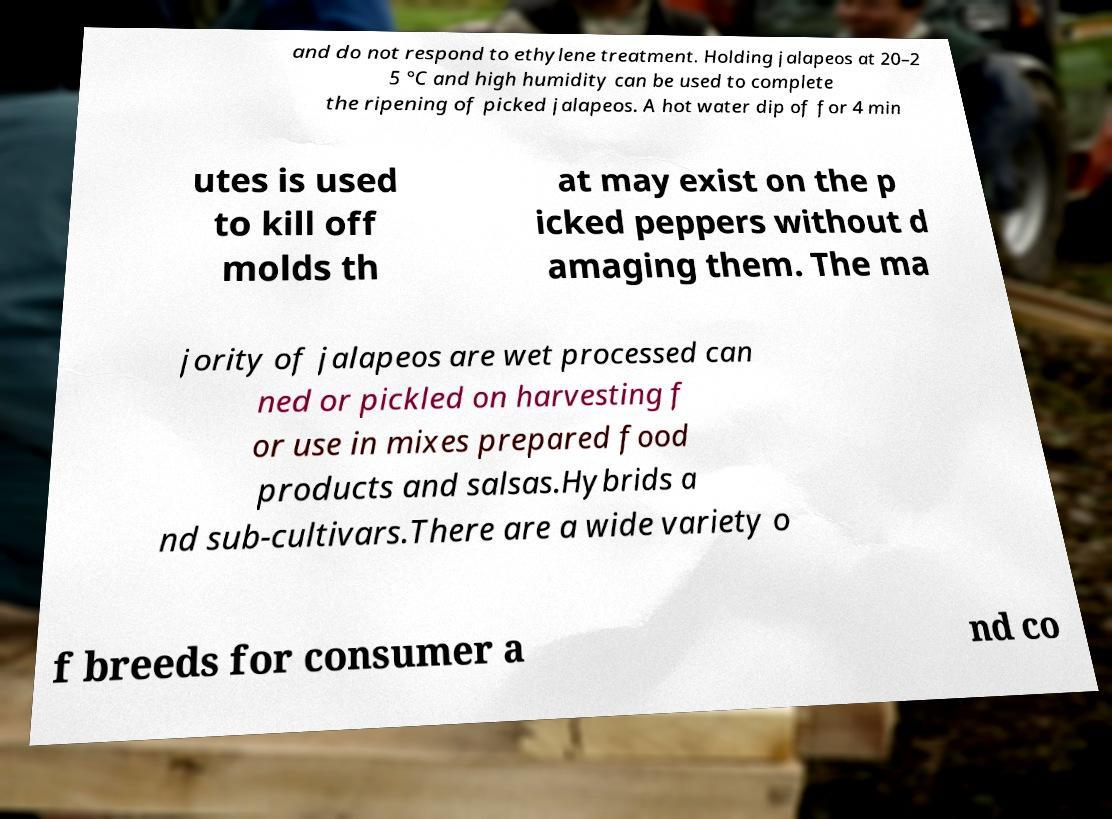Please read and relay the text visible in this image. What does it say? and do not respond to ethylene treatment. Holding jalapeos at 20–2 5 °C and high humidity can be used to complete the ripening of picked jalapeos. A hot water dip of for 4 min utes is used to kill off molds th at may exist on the p icked peppers without d amaging them. The ma jority of jalapeos are wet processed can ned or pickled on harvesting f or use in mixes prepared food products and salsas.Hybrids a nd sub-cultivars.There are a wide variety o f breeds for consumer a nd co 